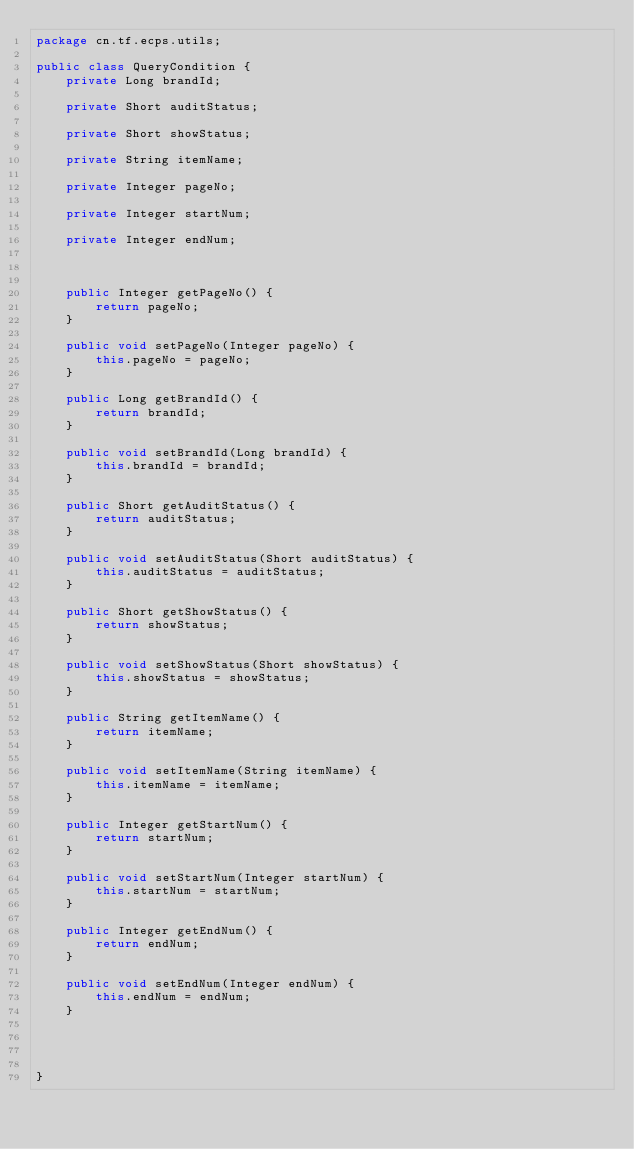Convert code to text. <code><loc_0><loc_0><loc_500><loc_500><_Java_>package cn.tf.ecps.utils;

public class QueryCondition {
	private Long brandId;
	
	private Short auditStatus;
	
	private Short showStatus;
	
	private String itemName;
	
	private Integer pageNo;
	
	private Integer startNum;
	
	private Integer endNum;
	
	

	public Integer getPageNo() {
		return pageNo;
	}

	public void setPageNo(Integer pageNo) {
		this.pageNo = pageNo;
	}

	public Long getBrandId() {
		return brandId;
	}

	public void setBrandId(Long brandId) {
		this.brandId = brandId;
	}

	public Short getAuditStatus() {
		return auditStatus;
	}

	public void setAuditStatus(Short auditStatus) {
		this.auditStatus = auditStatus;
	}

	public Short getShowStatus() {
		return showStatus;
	}

	public void setShowStatus(Short showStatus) {
		this.showStatus = showStatus;
	}

	public String getItemName() {
		return itemName;
	}

	public void setItemName(String itemName) {
		this.itemName = itemName;
	}

	public Integer getStartNum() {
		return startNum;
	}

	public void setStartNum(Integer startNum) {
		this.startNum = startNum;
	}

	public Integer getEndNum() {
		return endNum;
	}

	public void setEndNum(Integer endNum) {
		this.endNum = endNum;
	}
	
	
	

}
</code> 